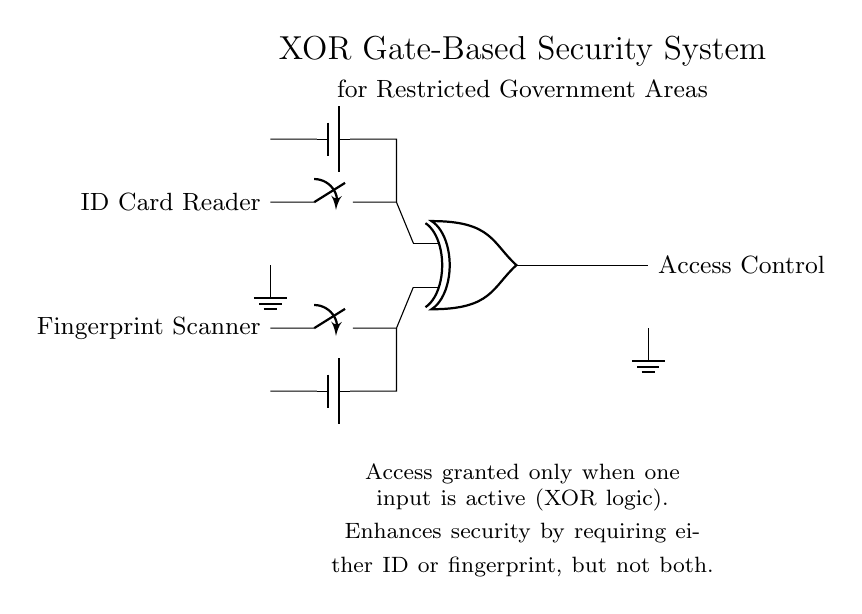What are the two input components of the circuit? The circuit includes an ID Card Reader and a Fingerprint Scanner, as shown in the diagram. These components are connected to the inputs of the XOR gate.
Answer: ID Card Reader and Fingerprint Scanner What is the functionality of the XOR gate in this security system? The XOR gate allows access only when one of the inputs is active, either the ID Card Reader or Fingerprint Scanner, but not both at the same time. This is a key property of the XOR logic gate.
Answer: Access granted only when one input is active What type of logic gate is used in this circuit? The diagram clearly labels the component at the center as an XOR gate. This specific type of gate performs the exclusive OR operation.
Answer: XOR How many power supplies are used in the circuit? The diagram indicates two separate battery symbols, one for each input component. Each input requires a power supply to function properly in this security setup.
Answer: Two What happens if both inputs are active? According to the functioning of the XOR gate, if both inputs are high, the output will be low, resulting in denied access, as the operation of the XOR requires only one input to be active.
Answer: Access denied What is the intended purpose of this circuit design in government areas? The purpose of this design is to enhance security by ensuring that access is controlled through a dual input system, requiring one form of authentication while disallowing simultaneous input.
Answer: Secure access control 